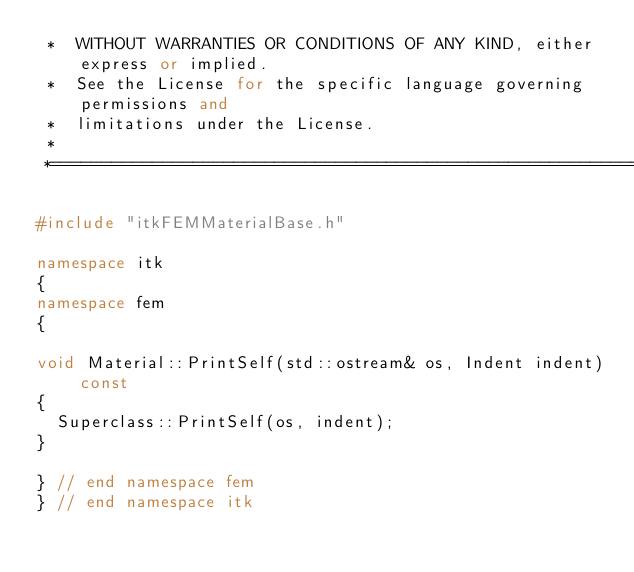<code> <loc_0><loc_0><loc_500><loc_500><_C++_> *  WITHOUT WARRANTIES OR CONDITIONS OF ANY KIND, either express or implied.
 *  See the License for the specific language governing permissions and
 *  limitations under the License.
 *
 *=========================================================================*/

#include "itkFEMMaterialBase.h"

namespace itk
{
namespace fem
{

void Material::PrintSelf(std::ostream& os, Indent indent) const
{
  Superclass::PrintSelf(os, indent);
}

} // end namespace fem
} // end namespace itk
</code> 